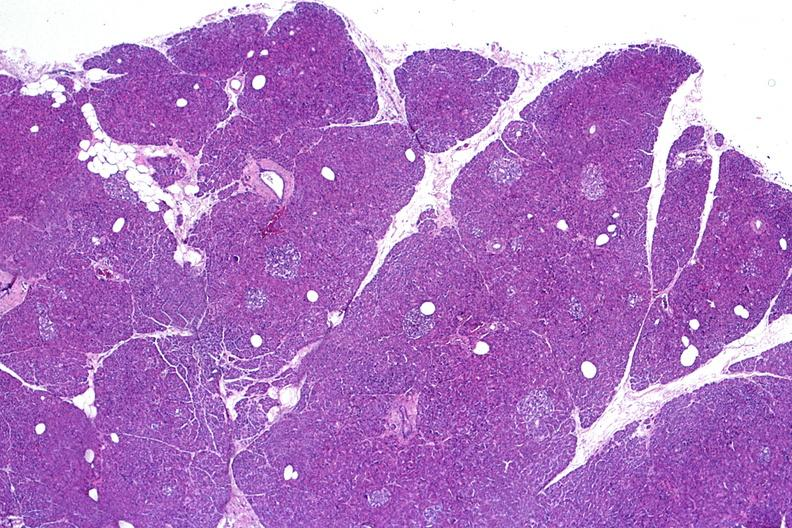what does this image show?
Answer the question using a single word or phrase. Normal pancreas 